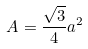Convert formula to latex. <formula><loc_0><loc_0><loc_500><loc_500>A = \frac { \sqrt { 3 } } { 4 } a ^ { 2 }</formula> 